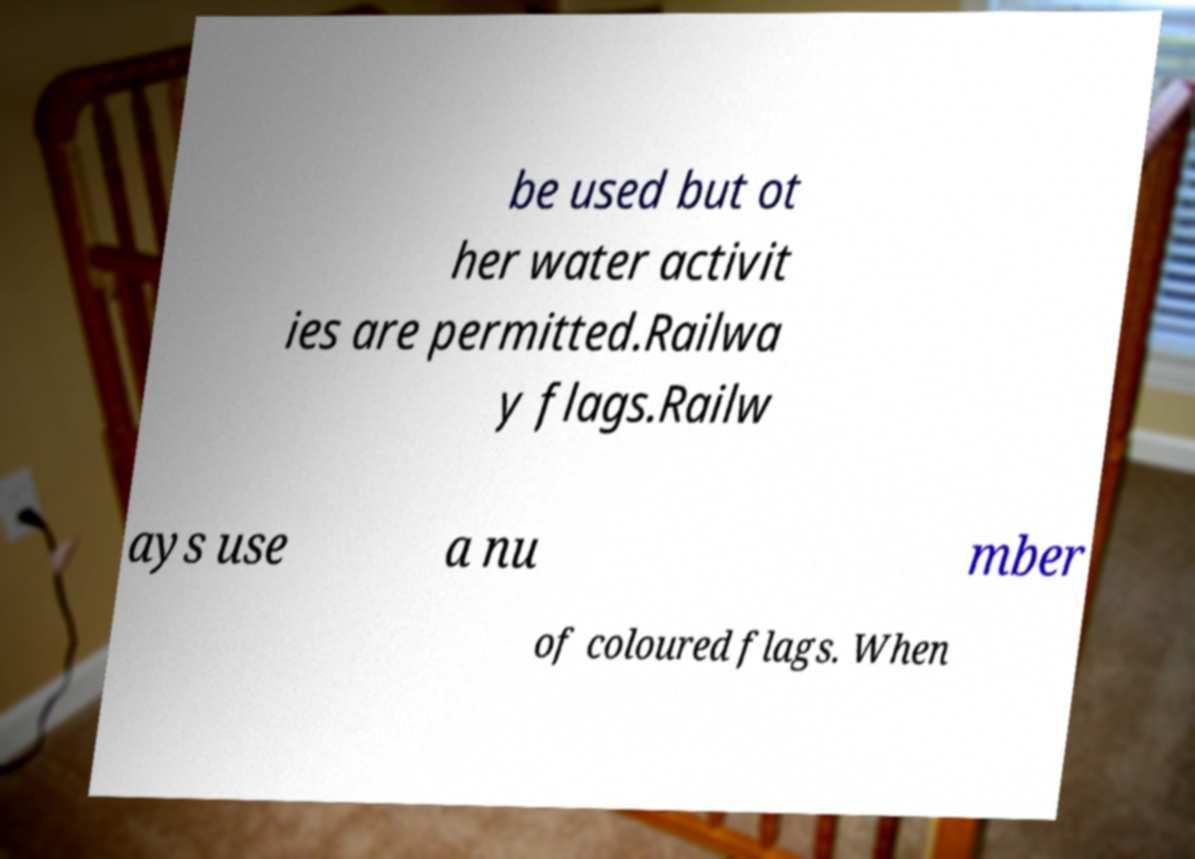What messages or text are displayed in this image? I need them in a readable, typed format. be used but ot her water activit ies are permitted.Railwa y flags.Railw ays use a nu mber of coloured flags. When 